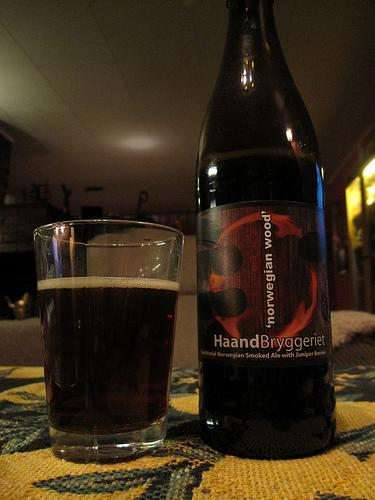Identify the key elements found in the background of the image. There is a tea kettle, fireplace, and white ceiling tiles in the background. Discuss the interesting features seen on the ceiling and how they affect the mood of the image. Light glares and white ceiling tiles create a bright atmosphere in the room. Describe the type of bottle and its contents shown in the image. The image shows a dark bottle containing Norwegian smoked ale with juniper berries. Describe the beverage found in the glass along with the noticeable elements on top of it. The glass contains a brown liquid, which appears to be ale, with a white foamy head. Mention the primary object on the table along with its contents. A clear glass full of ale is the primary object on the table. Mention two distinct features of the bottle in the image. The bottle has the brand "HaandBryggeriet" written on its side and has a berry design on the label. Explain the scene in the image with a focus on the placement of the bottle and the glass. A dark bottle of ale is placed on the table next to a glass filled with dark liquid and foam on top. What is the design on the table cover and what colors are present in it? The table cover has a floral design with a yellow and blue pattern. State the type of beverage and the brand shown in the image. The image features a bottle of traditional Norwegian smoked ale with the brand "HaandBryggeriet." Provide a brief description of the location where the bottle and the glass are placed. The bottle and glass are placed on a table with a yellow and blue floral table cover. 